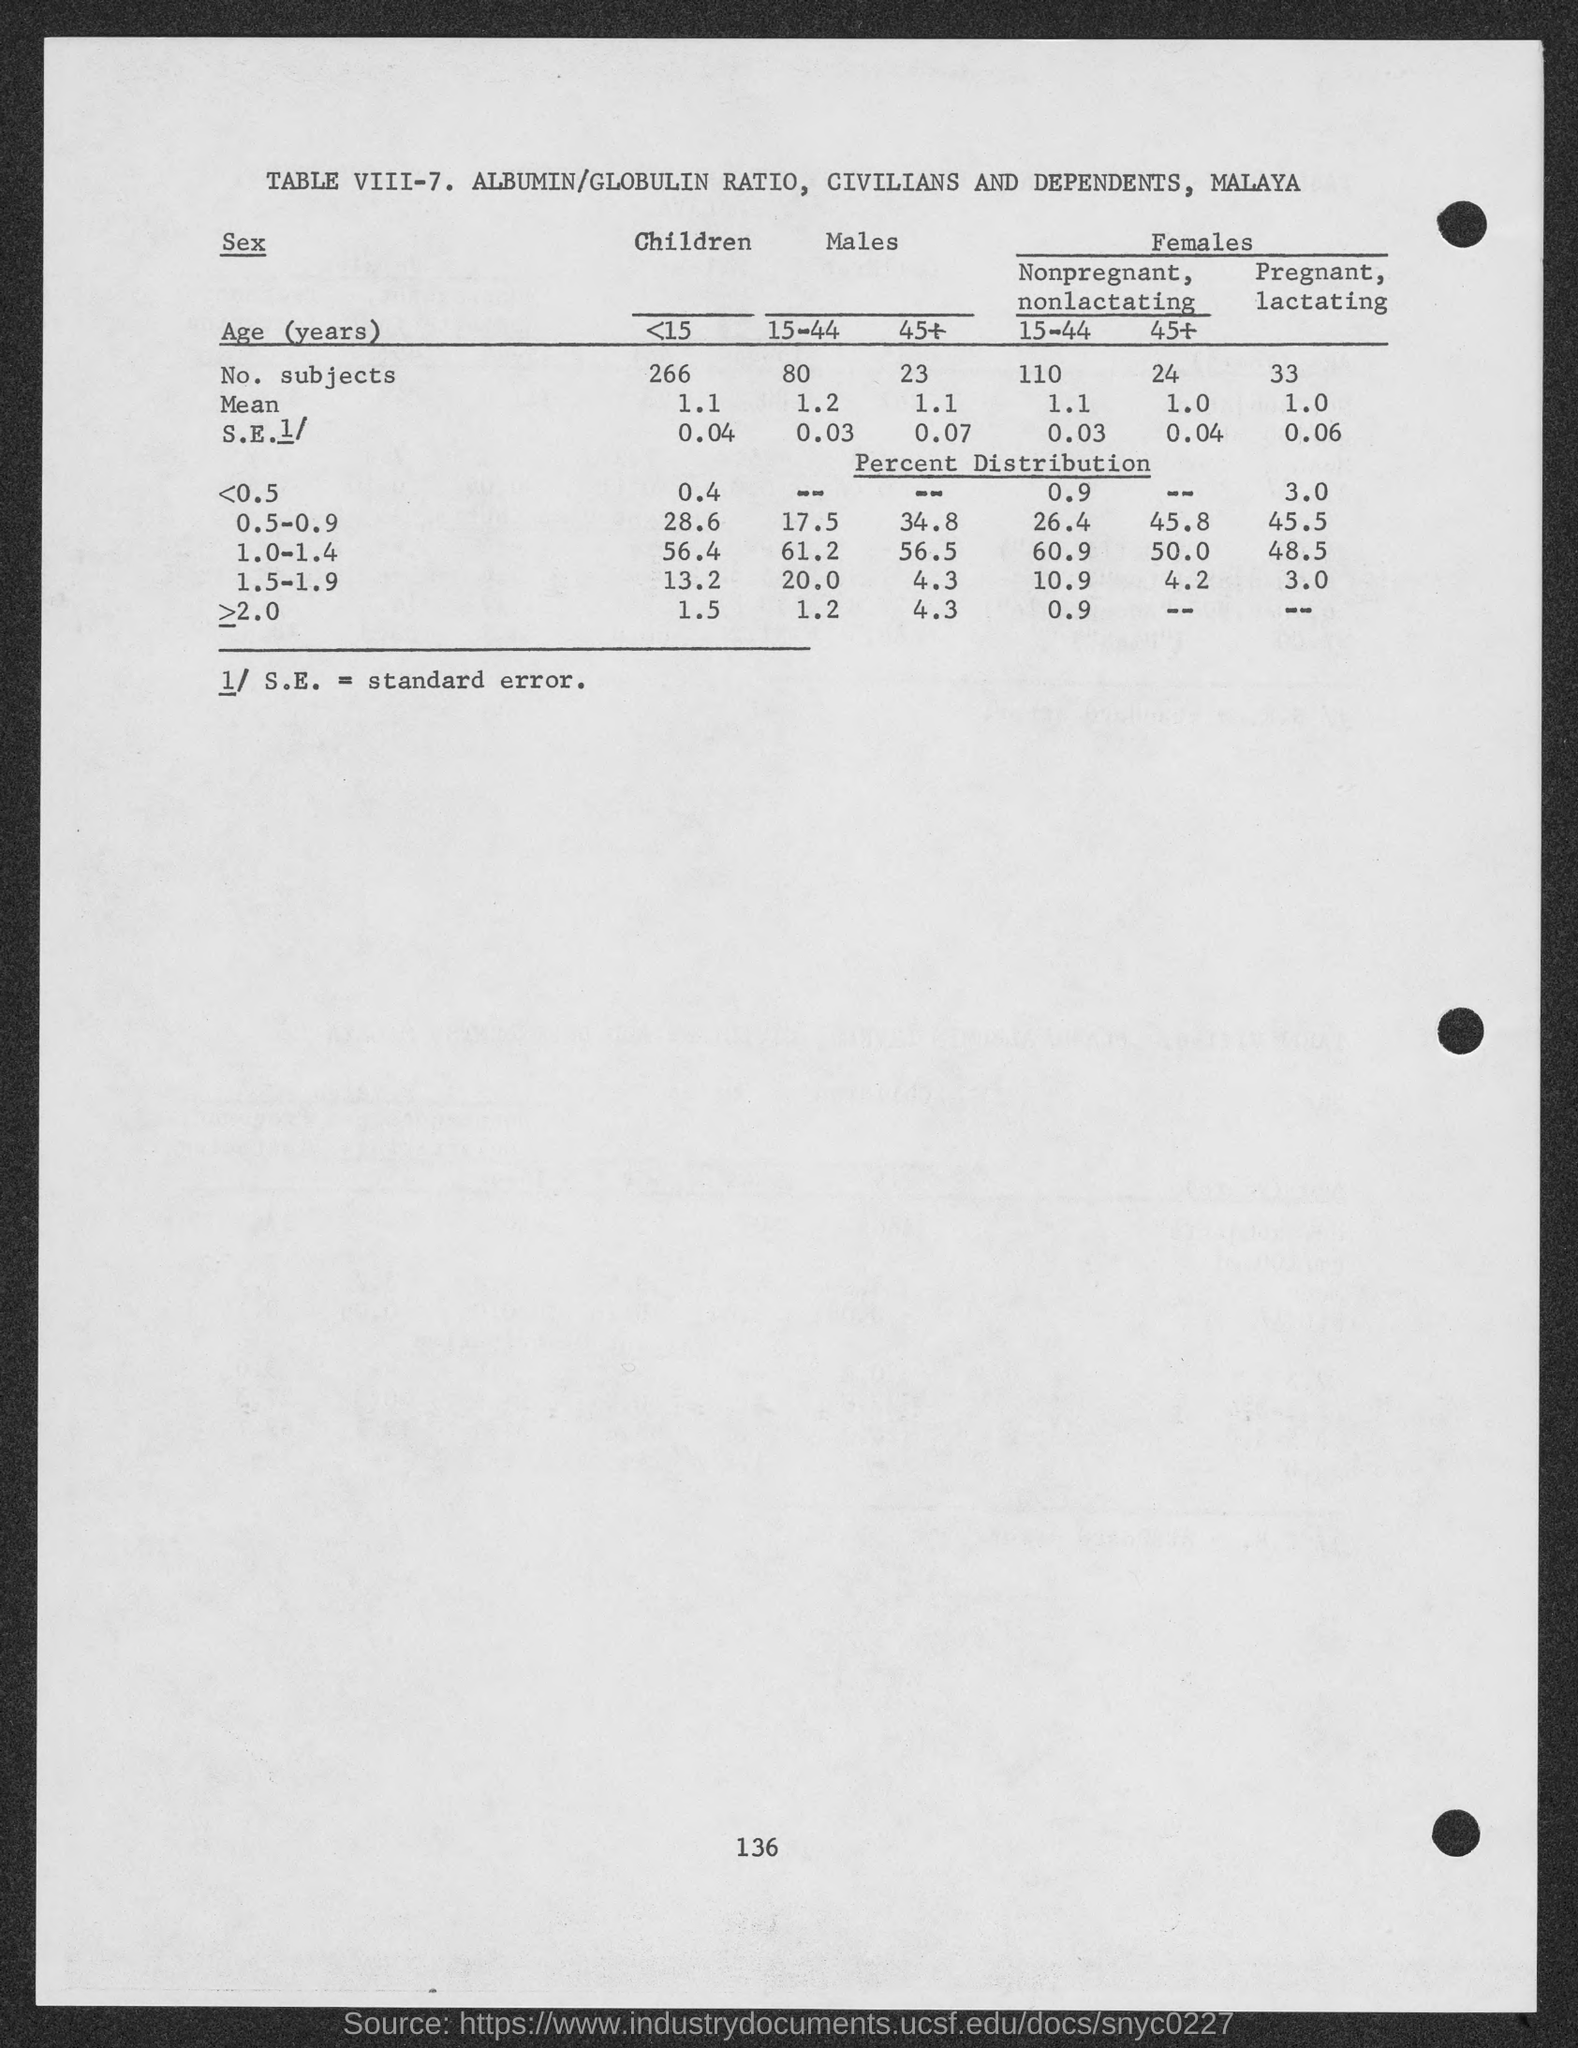What is the full form of S.E?
Offer a very short reply. STANDARD ERROR. What is the mean value of children below 15 yrs?
Offer a very short reply. 1.1. Which age group has the highest number of subjects?
Make the answer very short. <15. What is the standard error of the age group 15-44 of males?
Your answer should be compact. 0.03. 